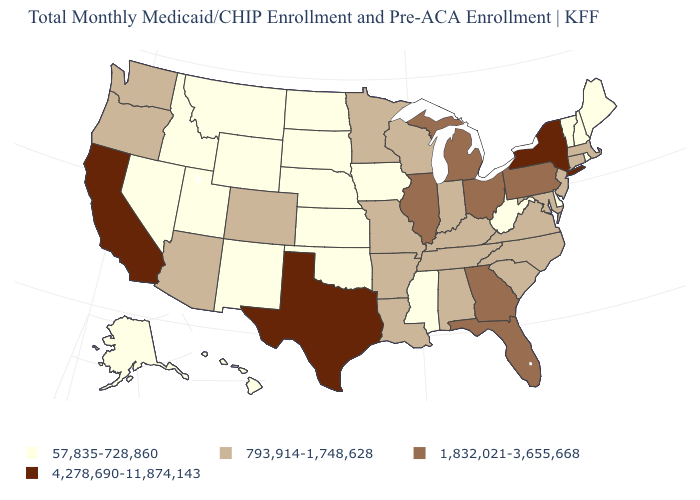Does Texas have the highest value in the USA?
Keep it brief. Yes. Does the map have missing data?
Quick response, please. No. What is the value of Rhode Island?
Keep it brief. 57,835-728,860. How many symbols are there in the legend?
Answer briefly. 4. What is the highest value in the Northeast ?
Be succinct. 4,278,690-11,874,143. Does Texas have the highest value in the South?
Give a very brief answer. Yes. Name the states that have a value in the range 4,278,690-11,874,143?
Short answer required. California, New York, Texas. How many symbols are there in the legend?
Be succinct. 4. Name the states that have a value in the range 57,835-728,860?
Answer briefly. Alaska, Delaware, Hawaii, Idaho, Iowa, Kansas, Maine, Mississippi, Montana, Nebraska, Nevada, New Hampshire, New Mexico, North Dakota, Oklahoma, Rhode Island, South Dakota, Utah, Vermont, West Virginia, Wyoming. Which states have the lowest value in the MidWest?
Short answer required. Iowa, Kansas, Nebraska, North Dakota, South Dakota. What is the highest value in the USA?
Concise answer only. 4,278,690-11,874,143. Name the states that have a value in the range 793,914-1,748,628?
Write a very short answer. Alabama, Arizona, Arkansas, Colorado, Connecticut, Indiana, Kentucky, Louisiana, Maryland, Massachusetts, Minnesota, Missouri, New Jersey, North Carolina, Oregon, South Carolina, Tennessee, Virginia, Washington, Wisconsin. What is the value of Alabama?
Be succinct. 793,914-1,748,628. What is the value of North Carolina?
Concise answer only. 793,914-1,748,628. Does Florida have a higher value than Texas?
Quick response, please. No. 